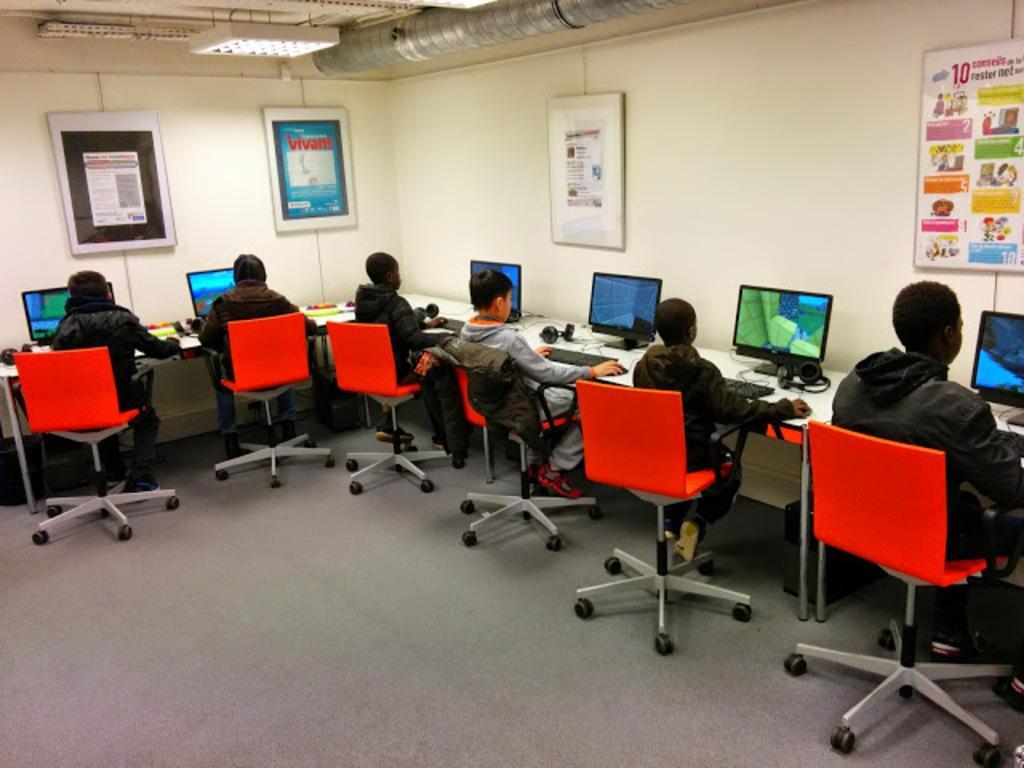Describe this image in one or two sentences. In the picture we can see six children sitting on the six chairs near the desk on the top of the desk there are systems of computer and keyboards and mouses. In the background we can see a wall, with photo frames and some information on it. 